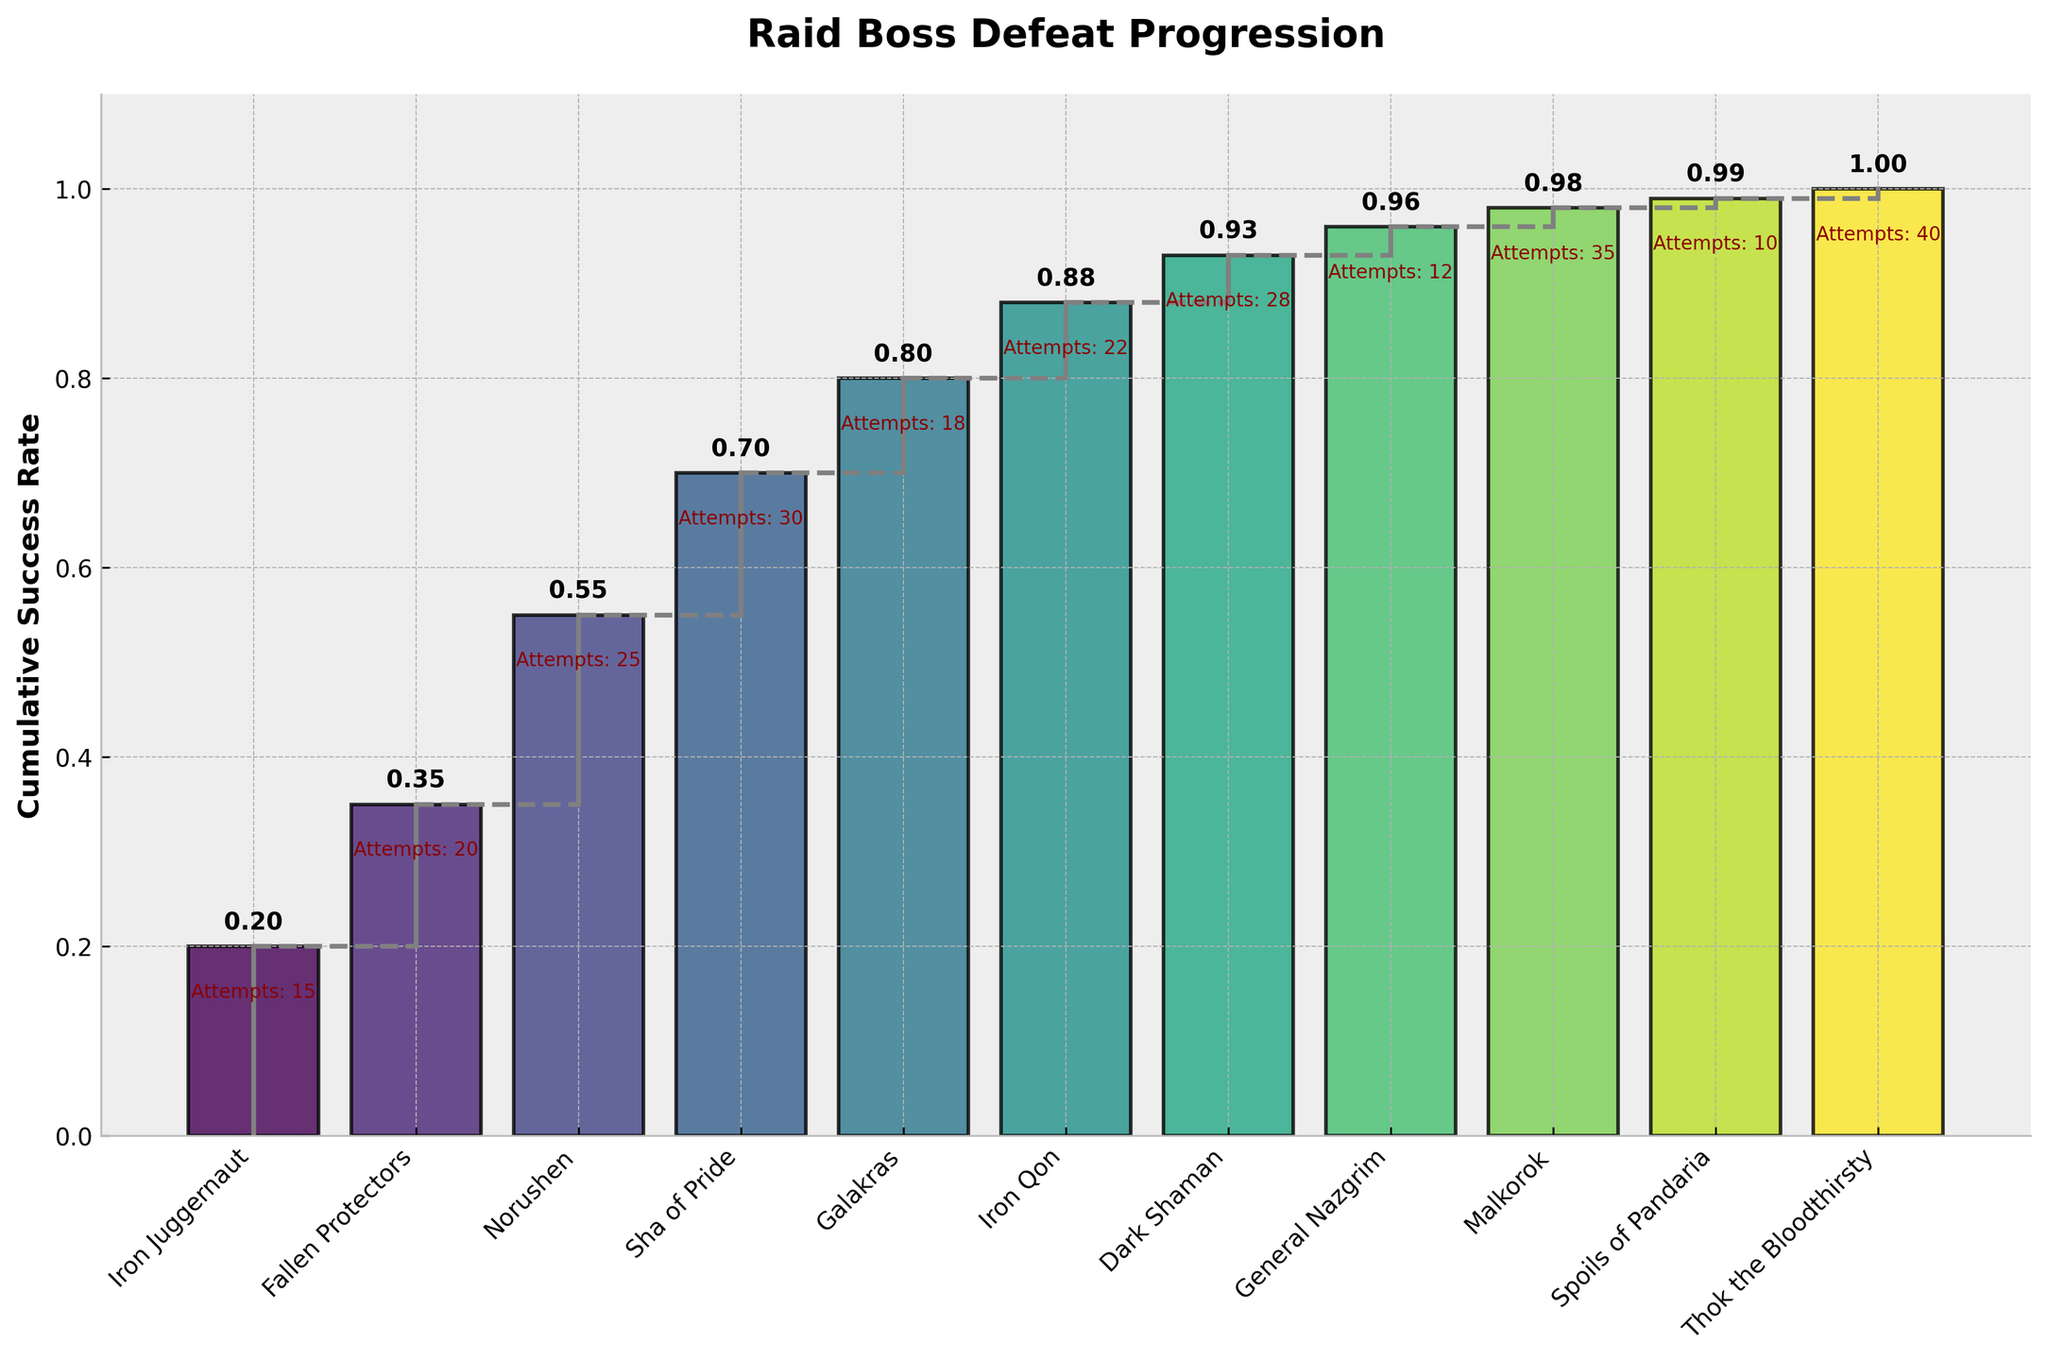What is the title of the figure? The title of the figure is located at the top and provides an overview of what the chart represents. "Raid Boss Defeat Progression" is written at the top of the chart, indicating the purpose of the chart.
Answer: Raid Boss Defeat Progression How many bosses are analyzed in the figure? Count the number of unique boss names on the x-axis. There are 11 different bosses listed from "Iron Juggernaut" to "Thok the Bloodthirsty."
Answer: 11 What is the cumulative success rate after defeating the Sha of Pride? Look at the data point related to Sha of Pride on the x-axis and read the corresponding cumulative success rate on the y-axis. The label near Sha of Pride indicates this rate.
Answer: 0.7 Which boss required the highest number of attempts to defeat? The number of attempts for each boss is annotated near the corresponding bars. Identify the boss with the highest number of attempts. "Thok the Bloodthirsty" has the highest attempt count of 40.
Answer: Thok the Bloodthirsty What is the change in cumulative success rate from Norushen to Galakras? Find the cumulative success rates for both Norushen and Galakras, which are 0.55 and 0.8 respectively. Subtract the value for Norushen from the value for Galakras. 0.8 - 0.55 = 0.25.
Answer: 0.25 How many bosses have a cumulative success rate greater than or equal to 0.9? Count the number of bosses for which the cumulative success rate is 0.9 or higher. There are four such bosses: Iron Qon, Dark Shaman, General Nazgrim, Malkorok, Spoils of Pandaria, and Thok the Bloodthirsty.
Answer: 6 What is the total number of attempts for all the bosses? Sum the number of attempts for all bosses: 15 + 20 + 25 + 30 + 18 + 22 + 28 + 12 + 35 + 10 + 40 = 255.
Answer: 255 On average, how many attempts were required per boss? First, find the total number of attempts (255) and divide it by the number of bosses (11). 255 / 11 = 23.18.
Answer: 23.18 Which two bosses had the smallest increase in cumulative success rate? Compare the differences in cumulative success rates between consecutive bosses and identify the smallest increase. The rate from Dark Shaman (0.93) to General Nazgrim (0.96) and from Malkorok (0.98) to Spoils of Pandaria (0.99) are both the smallest increases, each being 0.03.
Answer: Dark Shaman to General Nazgrim, Malkorok to Spoils of Pandaria For which boss did the cumulative success rate first exceed 0.5? Identify the first boss for which the cumulative success rate surpasses 50%. The cumulative success rate exceeds 0.5 at Norushen with a rate of 0.55.
Answer: Norushen 